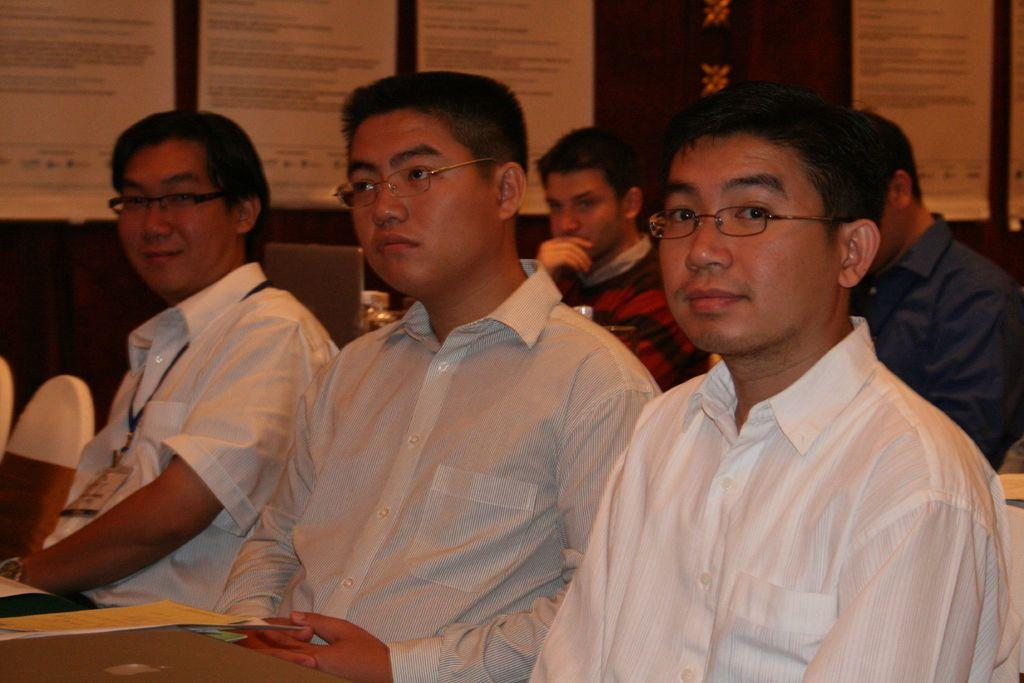What are the people in the image doing? The people in the image are sitting on chairs. Can you describe the appearance of the people in the front? The three people in the front are wearing white shirts and spectacles. What electronic device is visible in the image? There is a laptop in the image. What is attached to the back of the laptop? Papers are attached at the back of the laptop. Can you see a trail of beans behind the people in the image? There is no trail of beans visible in the image. 